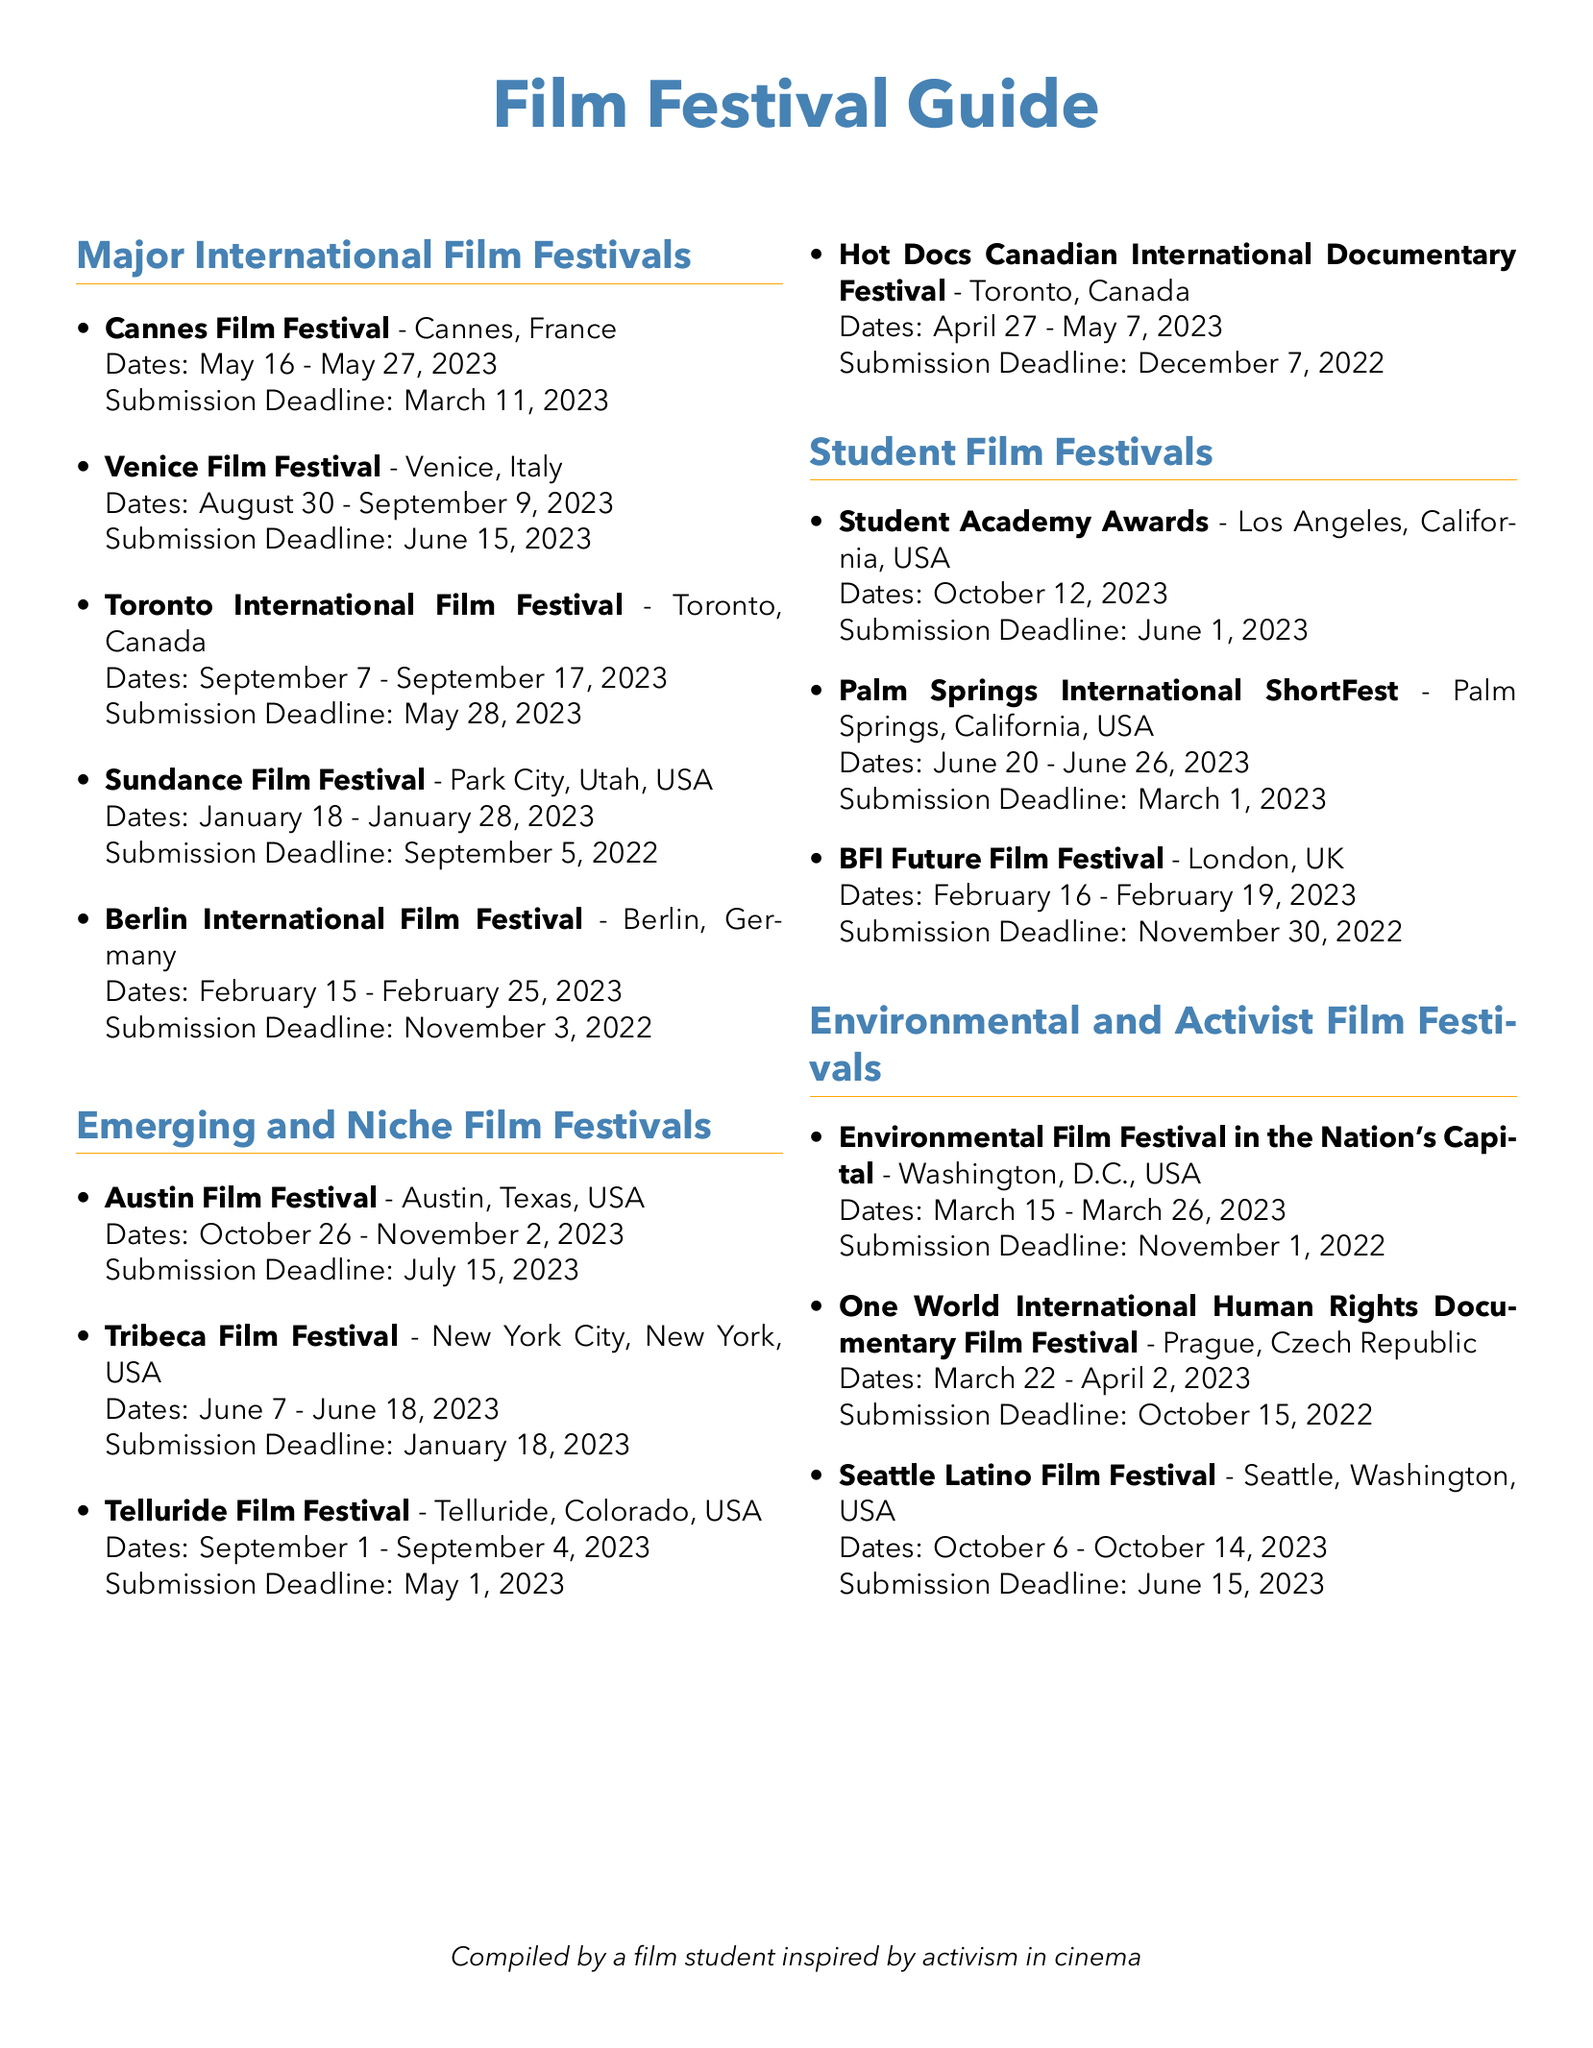What are the dates for the Cannes Film Festival? The Cannes Film Festival takes place from May 16 to May 27, 2023.
Answer: May 16 - May 27, 2023 What is the submission deadline for the Venice Film Festival? The submission deadline for the Venice Film Festival is June 15, 2023.
Answer: June 15, 2023 Which festival is scheduled for October 12, 2023? The Student Academy Awards is held on October 12, 2023.
Answer: Student Academy Awards What city hosts the Toronto International Film Festival? The Toronto International Film Festival takes place in Toronto, Canada.
Answer: Toronto, Canada How many days does the Seattle Latino Film Festival run? The Seattle Latino Film Festival runs from October 6 to October 14, 2023, lasting 9 days.
Answer: 9 days Which festival has a submission deadline of March 1, 2023? The Palm Springs International ShortFest has a submission deadline of March 1, 2023.
Answer: Palm Springs International ShortFest What is the name of a festival focused on environmental issues? The Environmental Film Festival in the Nation's Capital focuses on environmental issues.
Answer: Environmental Film Festival in the Nation's Capital Which international festival takes place in Berlin? The Berlin International Film Festival takes place in Berlin, Germany.
Answer: Berlin International Film Festival 